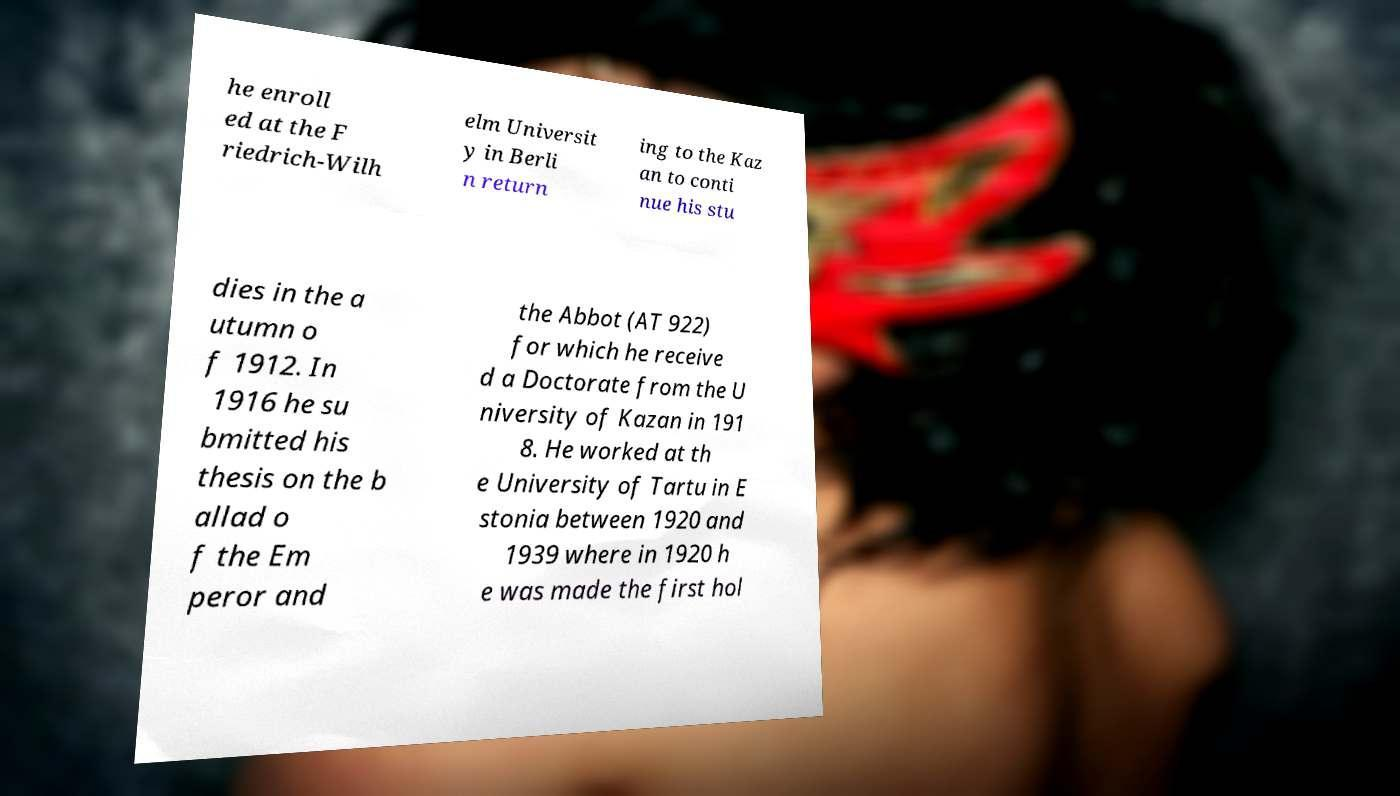For documentation purposes, I need the text within this image transcribed. Could you provide that? he enroll ed at the F riedrich-Wilh elm Universit y in Berli n return ing to the Kaz an to conti nue his stu dies in the a utumn o f 1912. In 1916 he su bmitted his thesis on the b allad o f the Em peror and the Abbot (AT 922) for which he receive d a Doctorate from the U niversity of Kazan in 191 8. He worked at th e University of Tartu in E stonia between 1920 and 1939 where in 1920 h e was made the first hol 